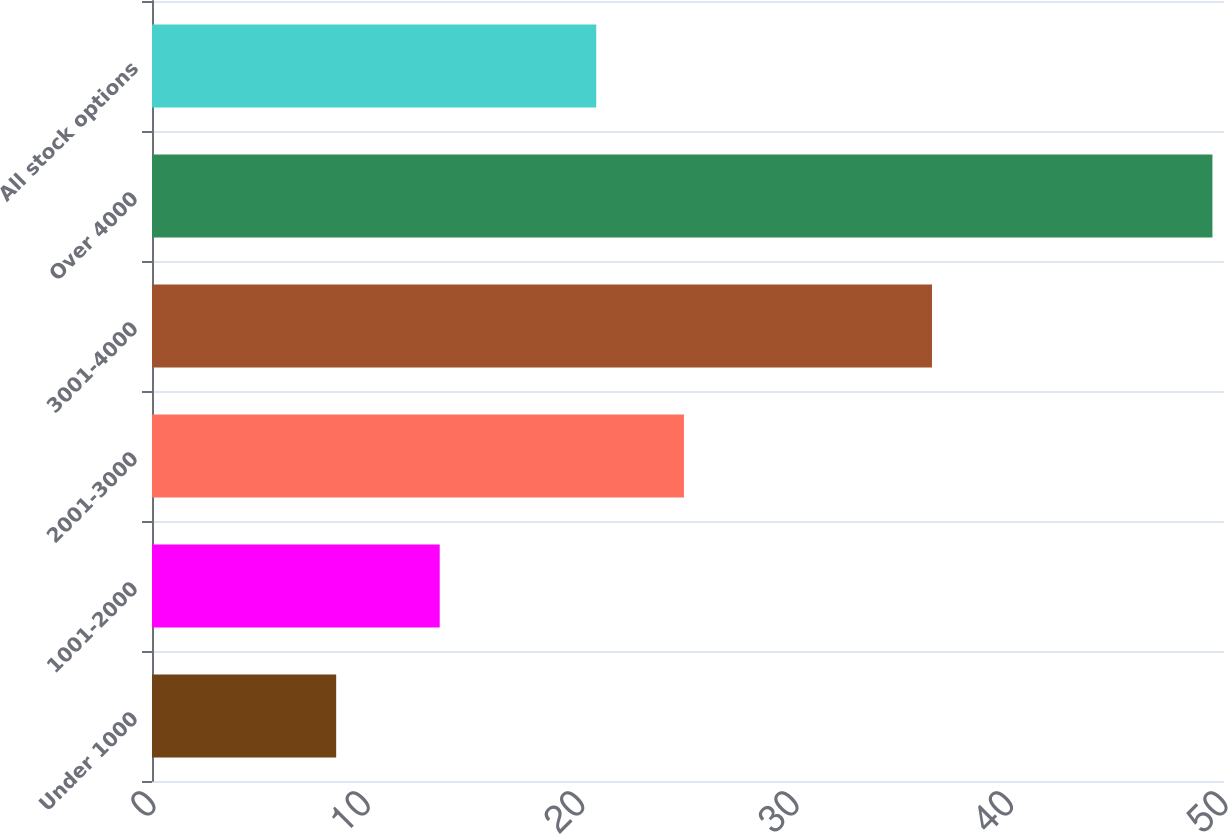Convert chart. <chart><loc_0><loc_0><loc_500><loc_500><bar_chart><fcel>Under 1000<fcel>1001-2000<fcel>2001-3000<fcel>3001-4000<fcel>Over 4000<fcel>All stock options<nl><fcel>8.59<fcel>13.42<fcel>24.81<fcel>36.38<fcel>49.46<fcel>20.72<nl></chart> 